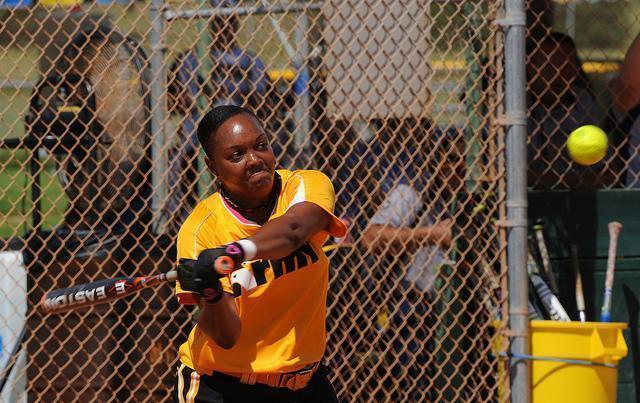Judging by the batters expression how hard is she swinging the bat?
Pick the correct solution from the four options below to address the question.
Options: Very soft, very hard, soft, somewhat hard. Very hard. 